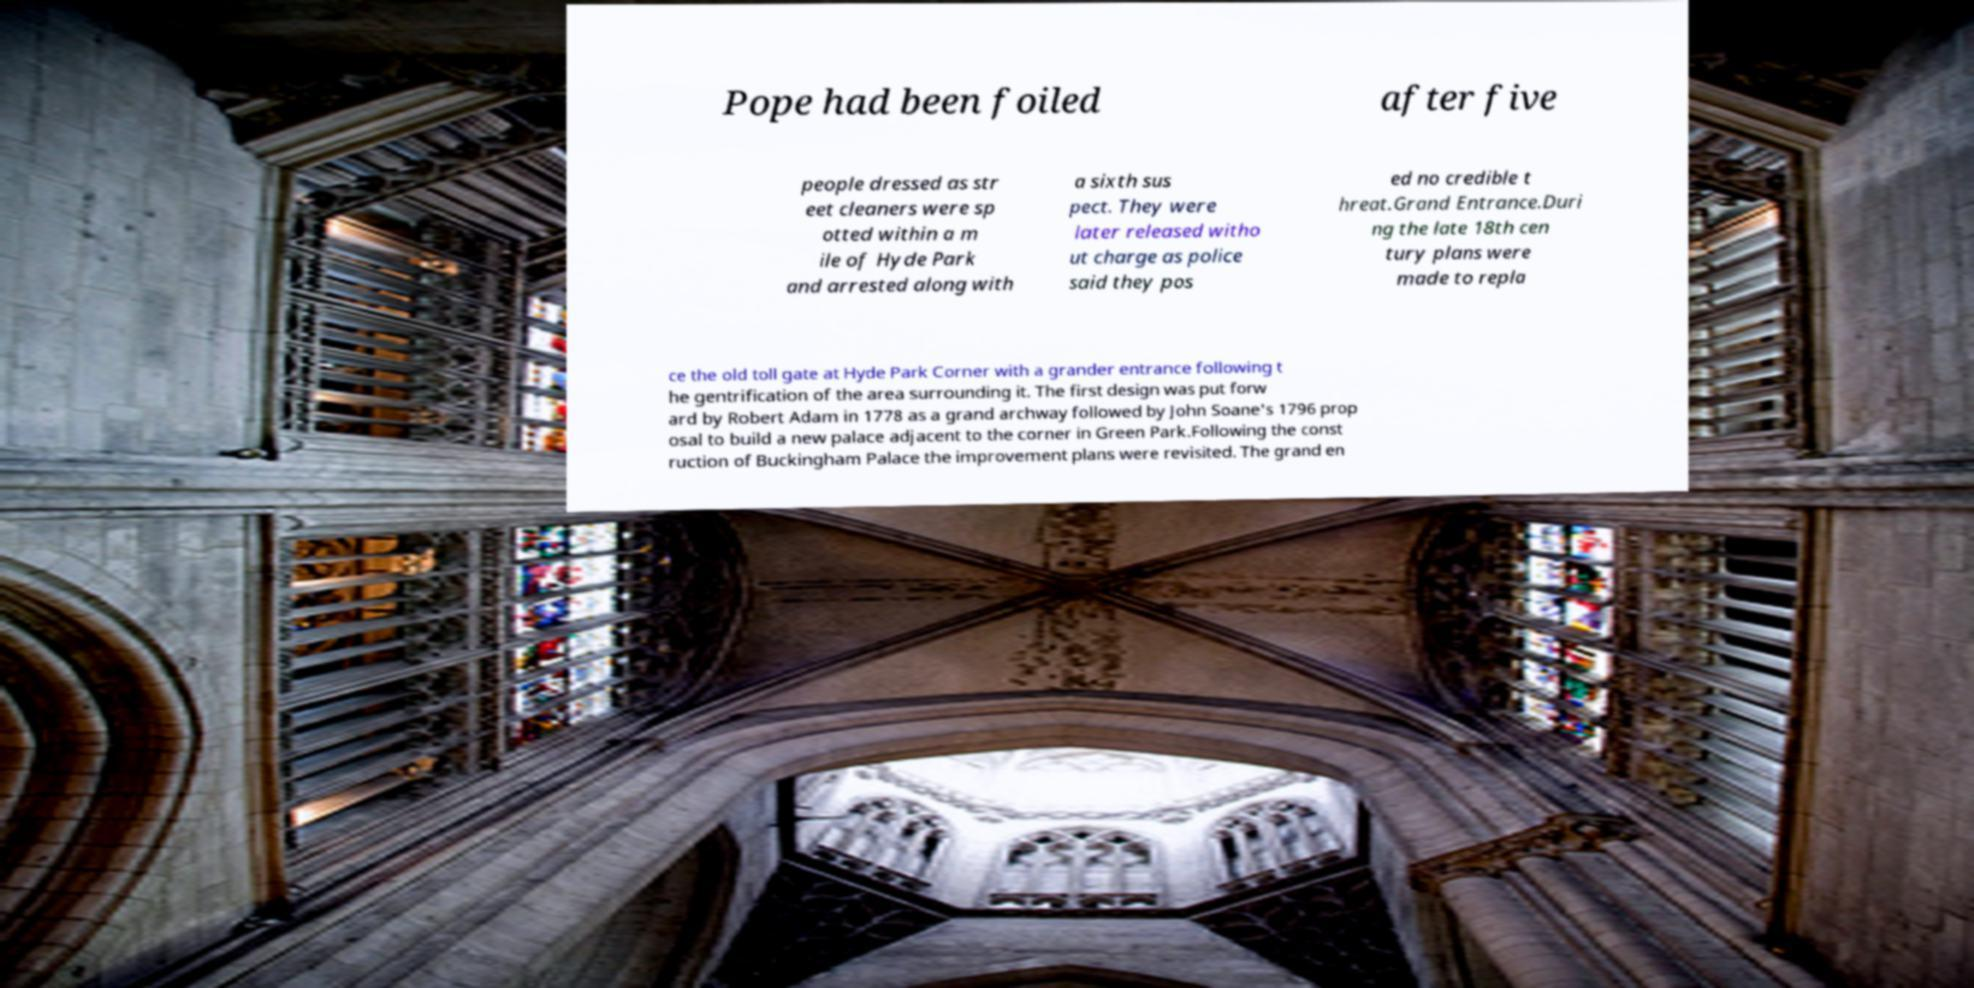For documentation purposes, I need the text within this image transcribed. Could you provide that? Pope had been foiled after five people dressed as str eet cleaners were sp otted within a m ile of Hyde Park and arrested along with a sixth sus pect. They were later released witho ut charge as police said they pos ed no credible t hreat.Grand Entrance.Duri ng the late 18th cen tury plans were made to repla ce the old toll gate at Hyde Park Corner with a grander entrance following t he gentrification of the area surrounding it. The first design was put forw ard by Robert Adam in 1778 as a grand archway followed by John Soane's 1796 prop osal to build a new palace adjacent to the corner in Green Park.Following the const ruction of Buckingham Palace the improvement plans were revisited. The grand en 